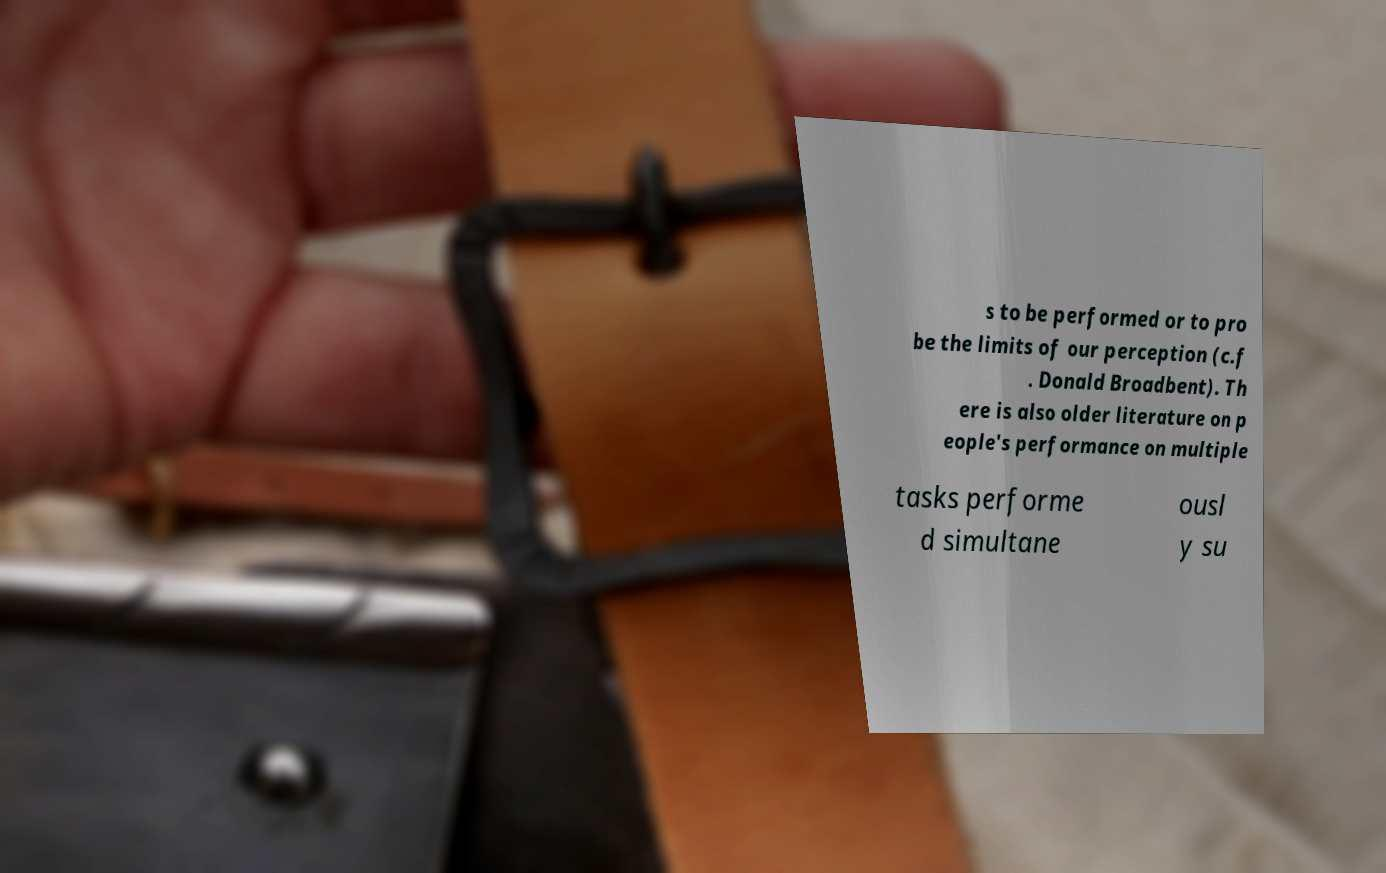Can you read and provide the text displayed in the image?This photo seems to have some interesting text. Can you extract and type it out for me? s to be performed or to pro be the limits of our perception (c.f . Donald Broadbent). Th ere is also older literature on p eople's performance on multiple tasks performe d simultane ousl y su 